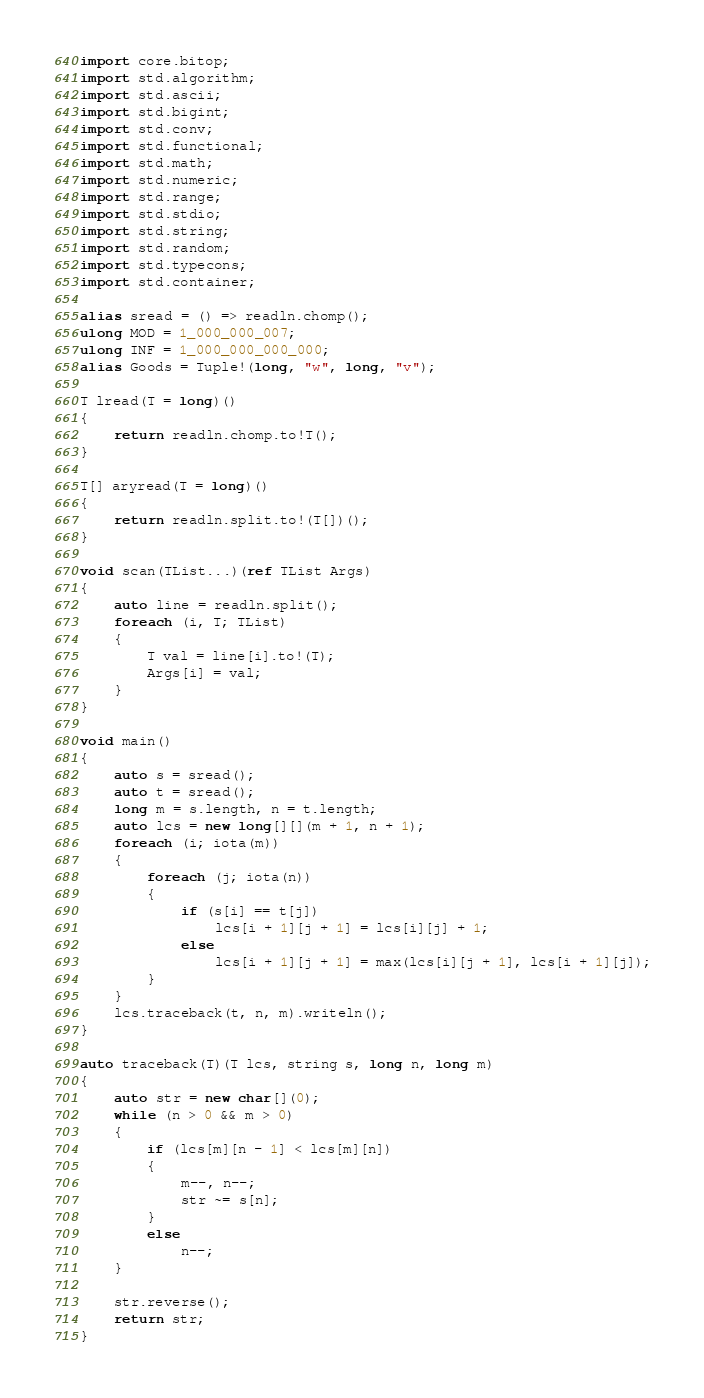<code> <loc_0><loc_0><loc_500><loc_500><_D_>import core.bitop;
import std.algorithm;
import std.ascii;
import std.bigint;
import std.conv;
import std.functional;
import std.math;
import std.numeric;
import std.range;
import std.stdio;
import std.string;
import std.random;
import std.typecons;
import std.container;

alias sread = () => readln.chomp();
ulong MOD = 1_000_000_007;
ulong INF = 1_000_000_000_000;
alias Goods = Tuple!(long, "w", long, "v");

T lread(T = long)()
{
    return readln.chomp.to!T();
}

T[] aryread(T = long)()
{
    return readln.split.to!(T[])();
}

void scan(TList...)(ref TList Args)
{
    auto line = readln.split();
    foreach (i, T; TList)
    {
        T val = line[i].to!(T);
        Args[i] = val;
    }
}

void main()
{
    auto s = sread();
    auto t = sread();
    long m = s.length, n = t.length;
    auto lcs = new long[][](m + 1, n + 1);
    foreach (i; iota(m))
    {
        foreach (j; iota(n))
        {
            if (s[i] == t[j])
                lcs[i + 1][j + 1] = lcs[i][j] + 1;
            else
                lcs[i + 1][j + 1] = max(lcs[i][j + 1], lcs[i + 1][j]);
        }
    }
    lcs.traceback(t, n, m).writeln();
}

auto traceback(T)(T lcs, string s, long n, long m)
{
    auto str = new char[](0);
    while (n > 0 && m > 0)
    {
        if (lcs[m][n - 1] < lcs[m][n])
        {
            m--, n--;
            str ~= s[n];
        }
        else
            n--;
    }

    str.reverse();
    return str;
}
</code> 